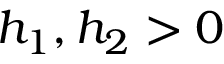Convert formula to latex. <formula><loc_0><loc_0><loc_500><loc_500>h _ { 1 } , h _ { 2 } > 0</formula> 